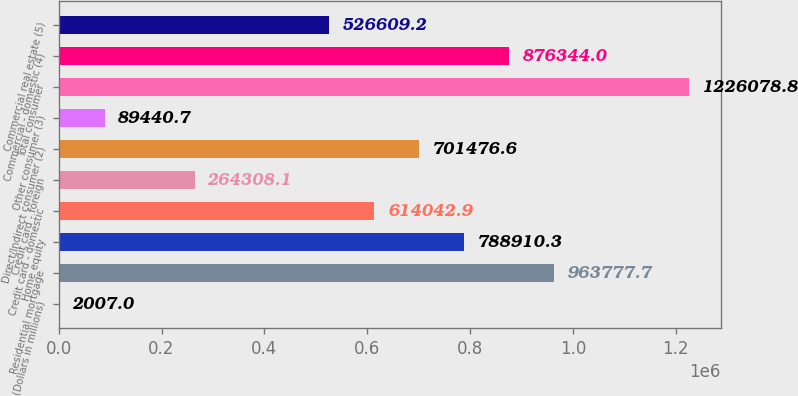Convert chart. <chart><loc_0><loc_0><loc_500><loc_500><bar_chart><fcel>(Dollars in millions)<fcel>Residential mortgage<fcel>Home equity<fcel>Credit card - domestic<fcel>Credit card - foreign<fcel>Direct/Indirect consumer (2)<fcel>Other consumer (3)<fcel>Total consumer<fcel>Commercial - domestic (4)<fcel>Commercial real estate (5)<nl><fcel>2007<fcel>963778<fcel>788910<fcel>614043<fcel>264308<fcel>701477<fcel>89440.7<fcel>1.22608e+06<fcel>876344<fcel>526609<nl></chart> 